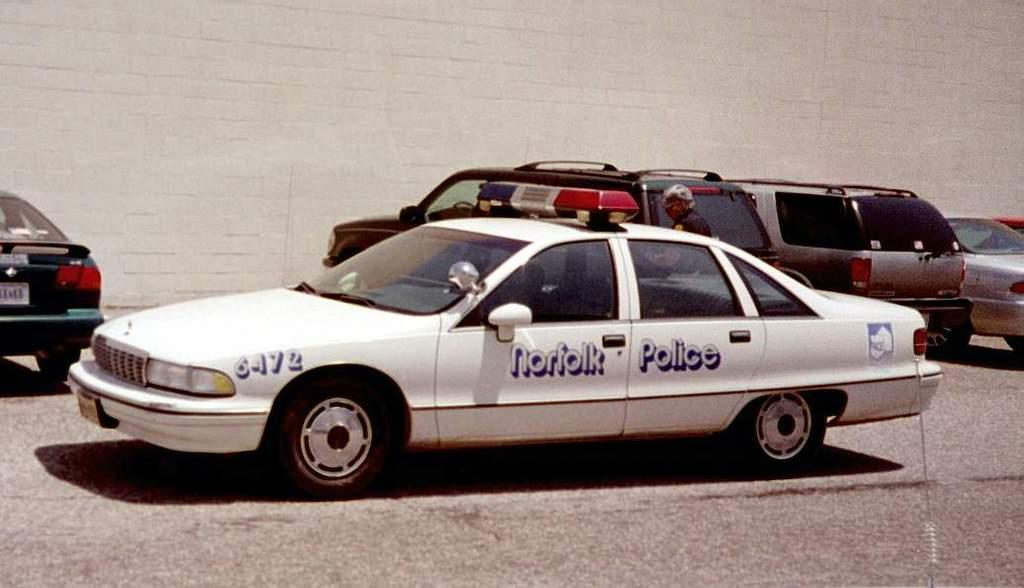What can be seen on the road in the image? There are vehicles on the road in the image. Are there any people on the road in the image? Yes, there is a person on the road in the image. What can be seen in the background of the image? There is a wall visible in the background of the image. Where is the shelf located in the image? There is no shelf present in the image. What verse can be heard being recited by the person on the road in the image? There is no indication of any verse being recited in the image, and the person's actions are not described. 